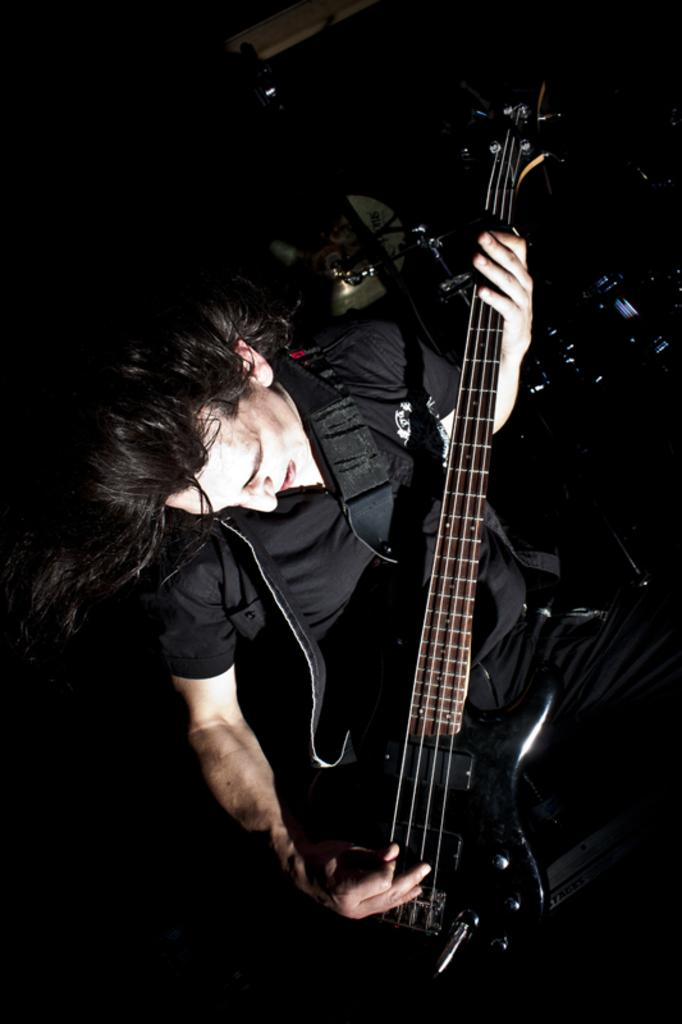Who is the main subject in the image? There is a man in the image. What is the man holding in his hand? The man is holding a guitar in his hand. Can you describe the objects visible behind the man? Unfortunately, the provided facts do not give any information about the objects behind the man. What is the color of the background in the image? The background of the image is black. What type of destruction can be seen in the image? There is no destruction present in the image. How does the expert play the guitar in the image? The provided facts do not mention an expert playing the guitar, nor do they give any information about how the guitar is played. 